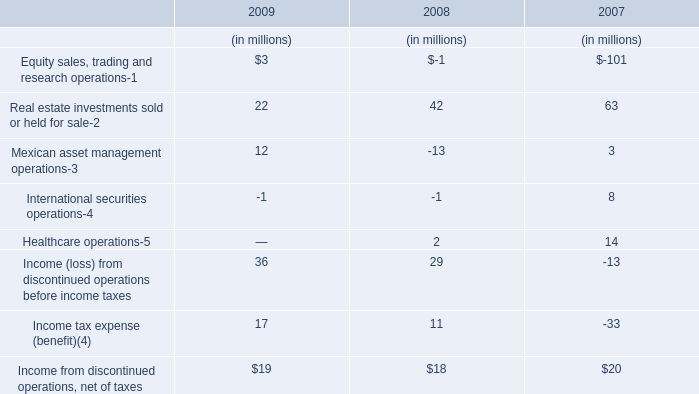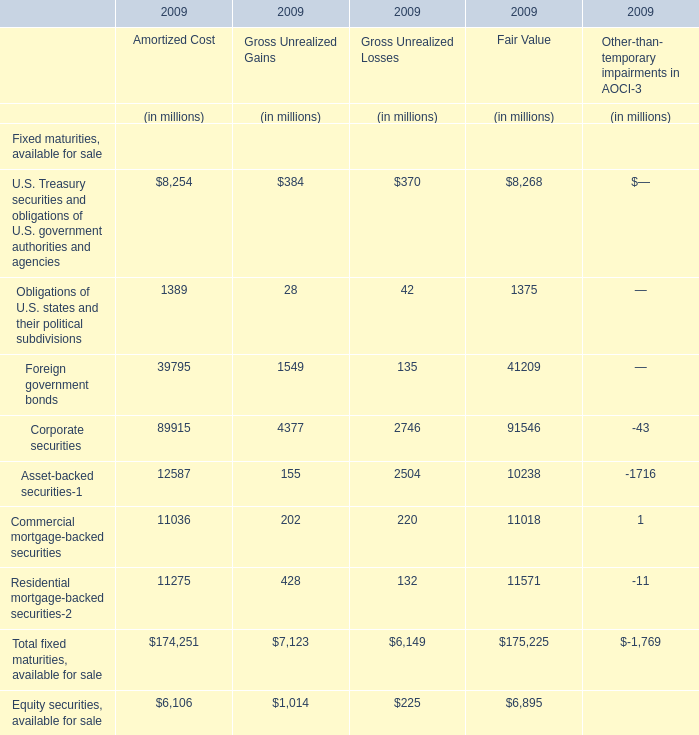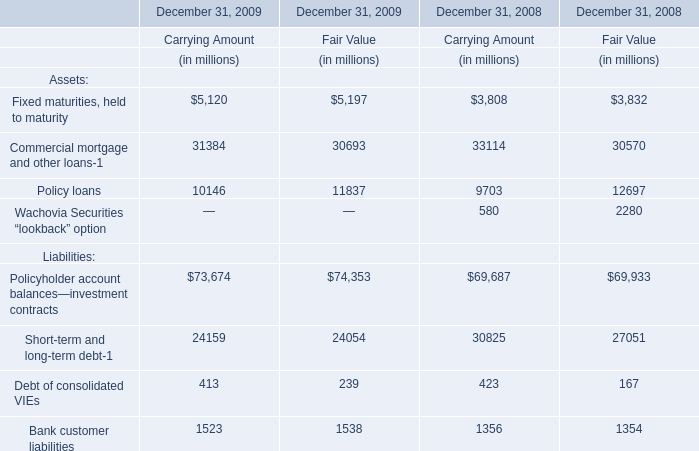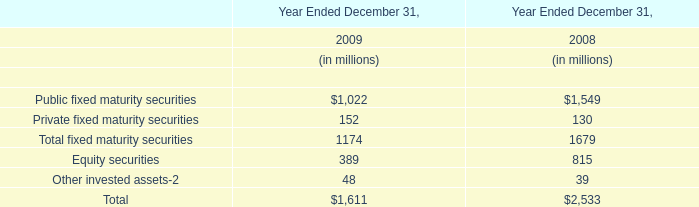What's the current increasing rate of Income tax expense (benefit)(4)? (in %) 
Computations: ((17 - 11) / 11)
Answer: 0.54545. 